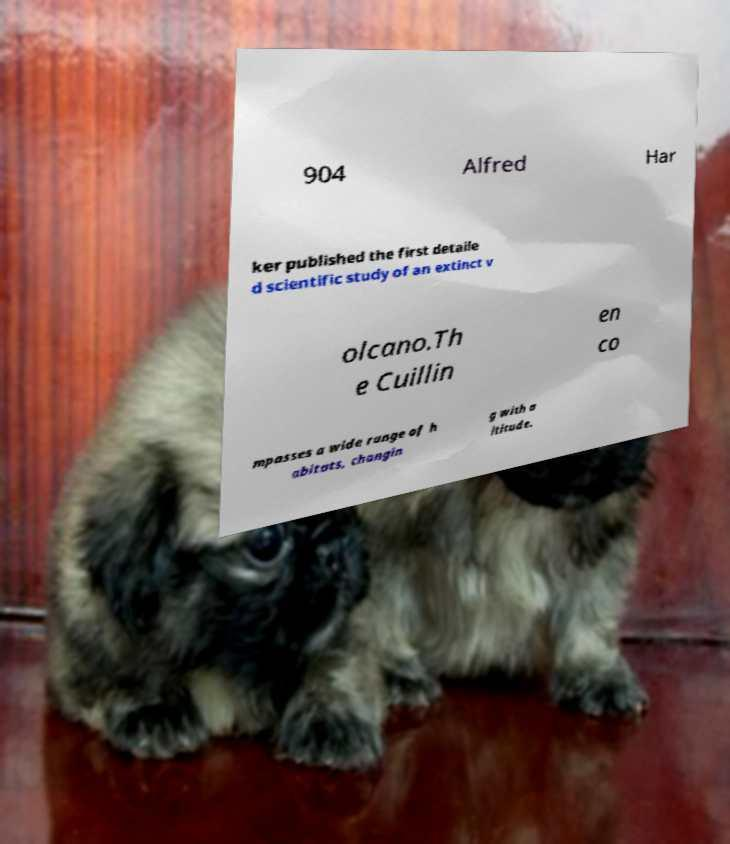What messages or text are displayed in this image? I need them in a readable, typed format. 904 Alfred Har ker published the first detaile d scientific study of an extinct v olcano.Th e Cuillin en co mpasses a wide range of h abitats, changin g with a ltitude. 